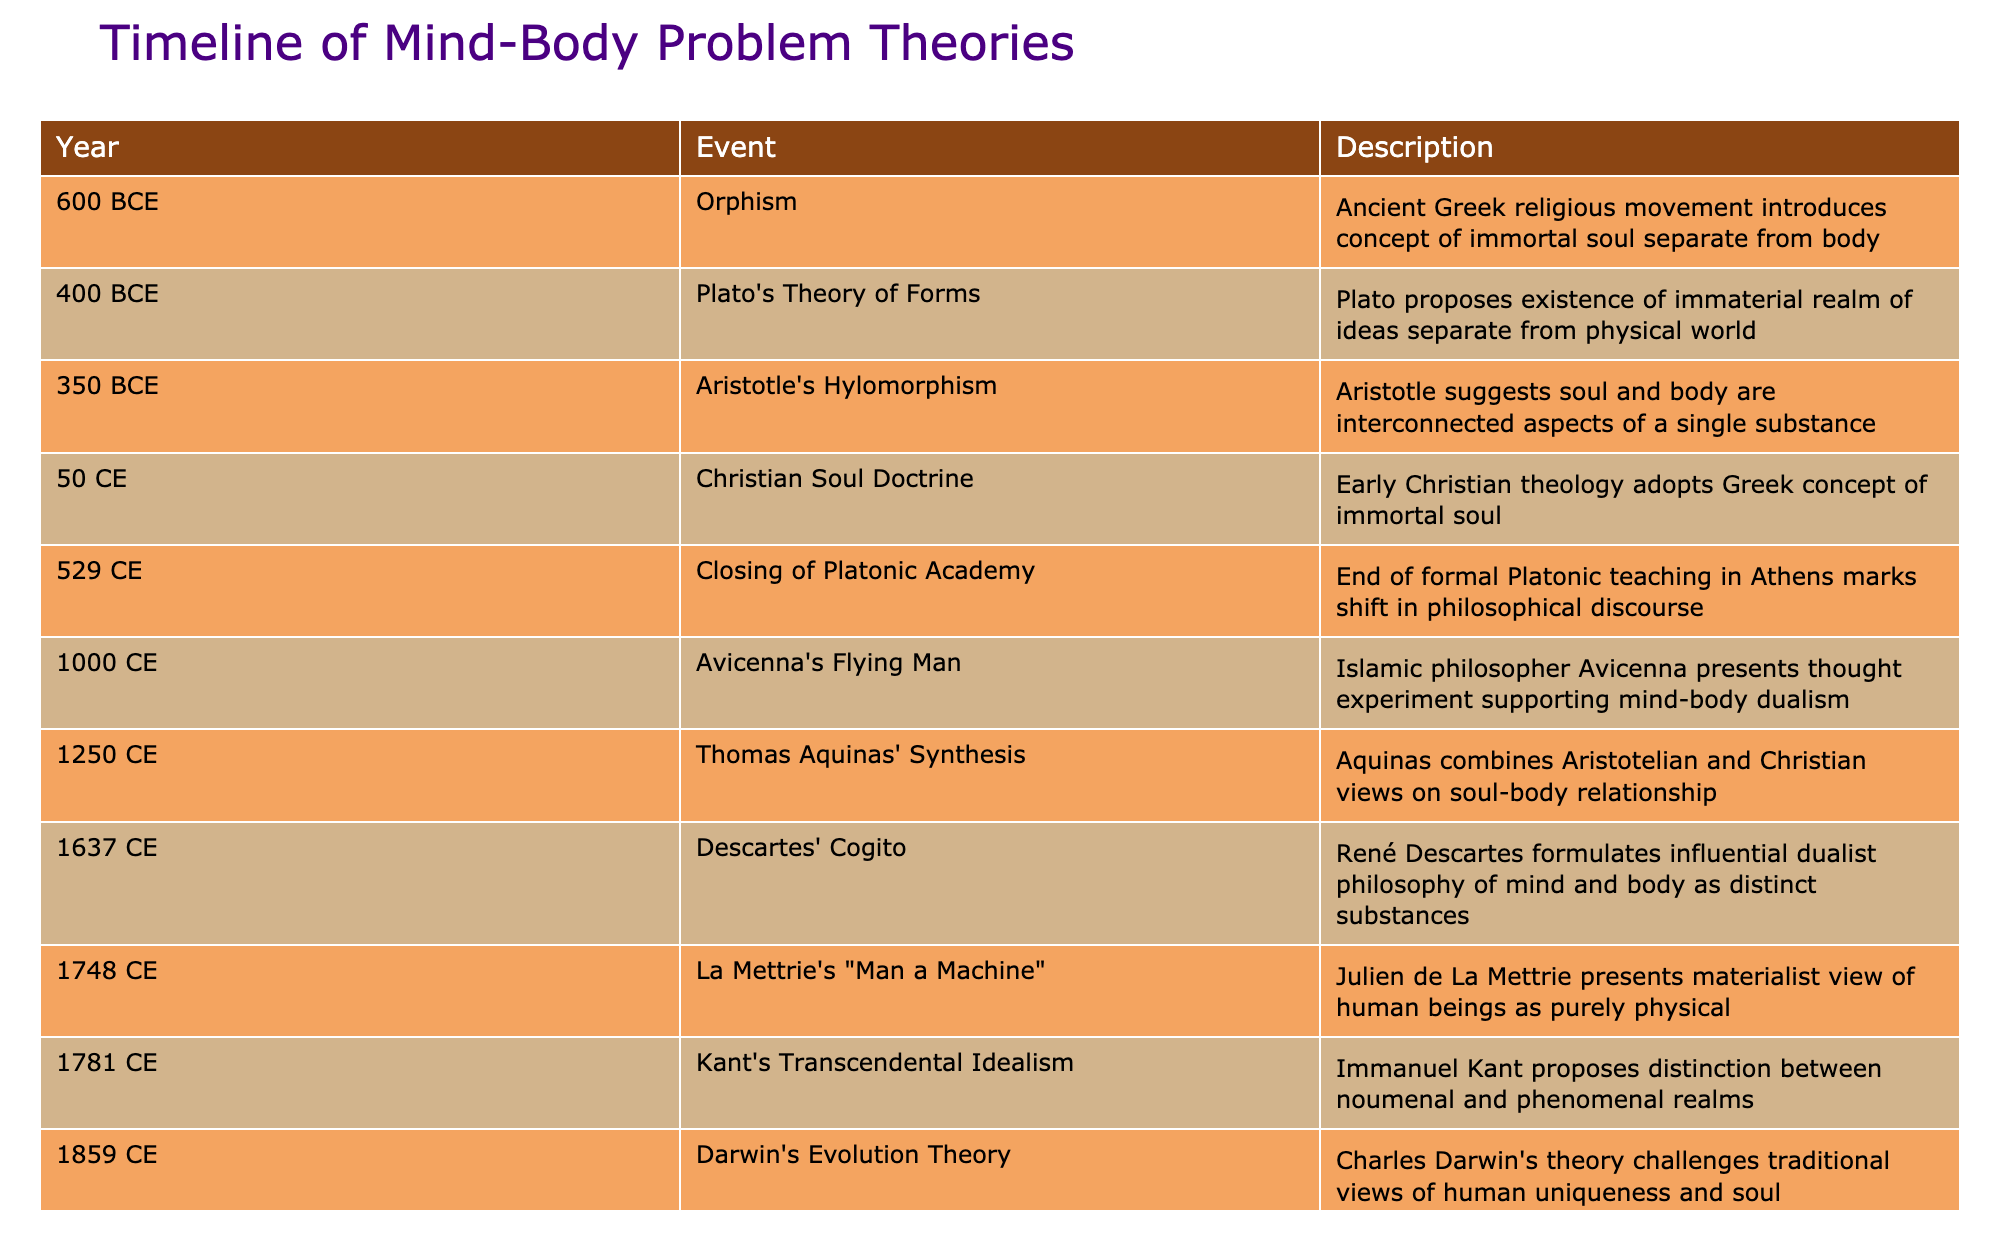What year did Descartes formulate his influential dualist philosophy? Descartes formulated his philosophy in 1637, as indicated in the table under the corresponding event.
Answer: 1637 What is the primary view proposed by Aristotle in 350 BCE regarding the relationship between mind and body? Aristotle suggested that the soul and body are interconnected aspects of a single substance, which is noted in his theory of hylomorphism in the table.
Answer: Interconnected aspects of a single substance Was Avicenna's Flying Man thought experiment supportive of dualism? Yes, the table states that Avicenna presented a thought experiment that supports mind-body dualism.
Answer: Yes How many events in the timeline occurred before 1000 CE? The events before 1000 CE are: Orphism (600 BCE), Plato's Theory of Forms (400 BCE), Aristotle's Hylomorphism (350 BCE), Christian Soul Doctrine (50 CE), and the Closing of Platonic Academy (529 CE). This totals 5 events.
Answer: 5 In what year did Kant propose his Transcendental Idealism, and what is its main premise? Kant proposed his Transcendental Idealism in 1781. The main premise is the distinction between noumenal and phenomenal realms, as per the table.
Answer: 1781; distinction between noumenal and phenomenal realms What is the difference in years between Ryle's criticism of Cartesian dualism and the presentation of La Mettrie's materialist view? Ryle's criticism occurred in 1949 and La Mettrie's presentation was in 1748. The difference in years is 1949 - 1748 = 201 years.
Answer: 201 years Did any of the events associated with the soul concept occur between 1250 CE and 1700 CE? Yes, Thomas Aquinas' Synthesis occurred in 1250 CE, and Descartes' Cogito occurred in 1637 CE, which falls within that range.
Answer: Yes What significant event marked a shift in philosophical discourse in the year 529 CE? The table states that the Closing of the Platonic Academy in 529 CE marked the end of formal Platonic teaching in Athens, indicating a pivotal shift.
Answer: Closing of the Platonic Academy How does the timeline reflect the evolution of dualistic views in the context of the soul's existence? The timeline shows the progression from Orphism (600 BCE) presenting the idea of an immortal soul, through various philosophies until modern formulations like Chalmers' Hard Problem, indicating a sustained interest and evolution in dualistic views throughout history.
Answer: Evolution of dualistic views from ancient to modern concepts of the soul 